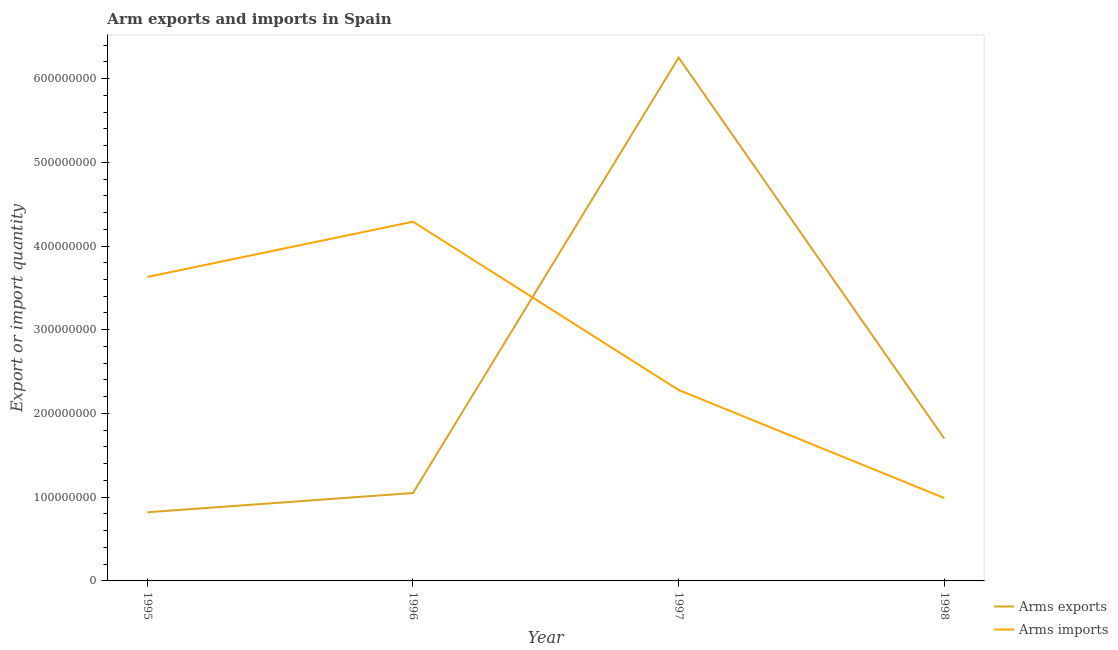How many different coloured lines are there?
Give a very brief answer. 2. Is the number of lines equal to the number of legend labels?
Provide a short and direct response. Yes. What is the arms exports in 1997?
Make the answer very short. 6.25e+08. Across all years, what is the maximum arms exports?
Offer a very short reply. 6.25e+08. Across all years, what is the minimum arms imports?
Offer a very short reply. 9.90e+07. In which year was the arms imports minimum?
Your answer should be very brief. 1998. What is the total arms imports in the graph?
Your answer should be very brief. 1.12e+09. What is the difference between the arms imports in 1995 and that in 1997?
Offer a terse response. 1.35e+08. What is the difference between the arms imports in 1997 and the arms exports in 1998?
Ensure brevity in your answer.  5.80e+07. What is the average arms imports per year?
Your response must be concise. 2.80e+08. In the year 1997, what is the difference between the arms imports and arms exports?
Ensure brevity in your answer.  -3.97e+08. What is the ratio of the arms imports in 1996 to that in 1998?
Give a very brief answer. 4.33. Is the arms imports in 1997 less than that in 1998?
Offer a very short reply. No. Is the difference between the arms imports in 1995 and 1996 greater than the difference between the arms exports in 1995 and 1996?
Your response must be concise. No. What is the difference between the highest and the second highest arms exports?
Ensure brevity in your answer.  4.55e+08. What is the difference between the highest and the lowest arms imports?
Ensure brevity in your answer.  3.30e+08. Is the sum of the arms imports in 1995 and 1998 greater than the maximum arms exports across all years?
Ensure brevity in your answer.  No. Is the arms imports strictly greater than the arms exports over the years?
Keep it short and to the point. No. How many lines are there?
Provide a short and direct response. 2. What is the difference between two consecutive major ticks on the Y-axis?
Provide a short and direct response. 1.00e+08. Are the values on the major ticks of Y-axis written in scientific E-notation?
Your answer should be compact. No. Does the graph contain grids?
Provide a succinct answer. No. How many legend labels are there?
Keep it short and to the point. 2. How are the legend labels stacked?
Your response must be concise. Vertical. What is the title of the graph?
Provide a succinct answer. Arm exports and imports in Spain. Does "Age 65(male)" appear as one of the legend labels in the graph?
Make the answer very short. No. What is the label or title of the X-axis?
Your answer should be compact. Year. What is the label or title of the Y-axis?
Provide a short and direct response. Export or import quantity. What is the Export or import quantity of Arms exports in 1995?
Ensure brevity in your answer.  8.20e+07. What is the Export or import quantity of Arms imports in 1995?
Keep it short and to the point. 3.63e+08. What is the Export or import quantity in Arms exports in 1996?
Make the answer very short. 1.05e+08. What is the Export or import quantity of Arms imports in 1996?
Offer a very short reply. 4.29e+08. What is the Export or import quantity of Arms exports in 1997?
Your answer should be very brief. 6.25e+08. What is the Export or import quantity in Arms imports in 1997?
Give a very brief answer. 2.28e+08. What is the Export or import quantity of Arms exports in 1998?
Your response must be concise. 1.70e+08. What is the Export or import quantity of Arms imports in 1998?
Offer a terse response. 9.90e+07. Across all years, what is the maximum Export or import quantity in Arms exports?
Offer a terse response. 6.25e+08. Across all years, what is the maximum Export or import quantity in Arms imports?
Give a very brief answer. 4.29e+08. Across all years, what is the minimum Export or import quantity in Arms exports?
Your response must be concise. 8.20e+07. Across all years, what is the minimum Export or import quantity of Arms imports?
Offer a very short reply. 9.90e+07. What is the total Export or import quantity of Arms exports in the graph?
Offer a very short reply. 9.82e+08. What is the total Export or import quantity in Arms imports in the graph?
Your response must be concise. 1.12e+09. What is the difference between the Export or import quantity of Arms exports in 1995 and that in 1996?
Offer a very short reply. -2.30e+07. What is the difference between the Export or import quantity in Arms imports in 1995 and that in 1996?
Make the answer very short. -6.60e+07. What is the difference between the Export or import quantity of Arms exports in 1995 and that in 1997?
Give a very brief answer. -5.43e+08. What is the difference between the Export or import quantity of Arms imports in 1995 and that in 1997?
Your answer should be very brief. 1.35e+08. What is the difference between the Export or import quantity in Arms exports in 1995 and that in 1998?
Offer a terse response. -8.80e+07. What is the difference between the Export or import quantity of Arms imports in 1995 and that in 1998?
Provide a short and direct response. 2.64e+08. What is the difference between the Export or import quantity of Arms exports in 1996 and that in 1997?
Provide a short and direct response. -5.20e+08. What is the difference between the Export or import quantity of Arms imports in 1996 and that in 1997?
Give a very brief answer. 2.01e+08. What is the difference between the Export or import quantity in Arms exports in 1996 and that in 1998?
Offer a terse response. -6.50e+07. What is the difference between the Export or import quantity of Arms imports in 1996 and that in 1998?
Provide a short and direct response. 3.30e+08. What is the difference between the Export or import quantity in Arms exports in 1997 and that in 1998?
Your answer should be compact. 4.55e+08. What is the difference between the Export or import quantity in Arms imports in 1997 and that in 1998?
Provide a succinct answer. 1.29e+08. What is the difference between the Export or import quantity in Arms exports in 1995 and the Export or import quantity in Arms imports in 1996?
Keep it short and to the point. -3.47e+08. What is the difference between the Export or import quantity of Arms exports in 1995 and the Export or import quantity of Arms imports in 1997?
Your answer should be very brief. -1.46e+08. What is the difference between the Export or import quantity of Arms exports in 1995 and the Export or import quantity of Arms imports in 1998?
Give a very brief answer. -1.70e+07. What is the difference between the Export or import quantity in Arms exports in 1996 and the Export or import quantity in Arms imports in 1997?
Your answer should be compact. -1.23e+08. What is the difference between the Export or import quantity of Arms exports in 1996 and the Export or import quantity of Arms imports in 1998?
Your answer should be very brief. 6.00e+06. What is the difference between the Export or import quantity of Arms exports in 1997 and the Export or import quantity of Arms imports in 1998?
Offer a very short reply. 5.26e+08. What is the average Export or import quantity of Arms exports per year?
Give a very brief answer. 2.46e+08. What is the average Export or import quantity of Arms imports per year?
Your response must be concise. 2.80e+08. In the year 1995, what is the difference between the Export or import quantity in Arms exports and Export or import quantity in Arms imports?
Provide a short and direct response. -2.81e+08. In the year 1996, what is the difference between the Export or import quantity of Arms exports and Export or import quantity of Arms imports?
Offer a terse response. -3.24e+08. In the year 1997, what is the difference between the Export or import quantity in Arms exports and Export or import quantity in Arms imports?
Keep it short and to the point. 3.97e+08. In the year 1998, what is the difference between the Export or import quantity in Arms exports and Export or import quantity in Arms imports?
Ensure brevity in your answer.  7.10e+07. What is the ratio of the Export or import quantity in Arms exports in 1995 to that in 1996?
Offer a very short reply. 0.78. What is the ratio of the Export or import quantity in Arms imports in 1995 to that in 1996?
Ensure brevity in your answer.  0.85. What is the ratio of the Export or import quantity of Arms exports in 1995 to that in 1997?
Keep it short and to the point. 0.13. What is the ratio of the Export or import quantity of Arms imports in 1995 to that in 1997?
Provide a short and direct response. 1.59. What is the ratio of the Export or import quantity in Arms exports in 1995 to that in 1998?
Offer a very short reply. 0.48. What is the ratio of the Export or import quantity in Arms imports in 1995 to that in 1998?
Your answer should be compact. 3.67. What is the ratio of the Export or import quantity in Arms exports in 1996 to that in 1997?
Keep it short and to the point. 0.17. What is the ratio of the Export or import quantity of Arms imports in 1996 to that in 1997?
Your answer should be very brief. 1.88. What is the ratio of the Export or import quantity in Arms exports in 1996 to that in 1998?
Offer a terse response. 0.62. What is the ratio of the Export or import quantity in Arms imports in 1996 to that in 1998?
Give a very brief answer. 4.33. What is the ratio of the Export or import quantity in Arms exports in 1997 to that in 1998?
Provide a short and direct response. 3.68. What is the ratio of the Export or import quantity of Arms imports in 1997 to that in 1998?
Your response must be concise. 2.3. What is the difference between the highest and the second highest Export or import quantity in Arms exports?
Keep it short and to the point. 4.55e+08. What is the difference between the highest and the second highest Export or import quantity in Arms imports?
Offer a very short reply. 6.60e+07. What is the difference between the highest and the lowest Export or import quantity of Arms exports?
Make the answer very short. 5.43e+08. What is the difference between the highest and the lowest Export or import quantity in Arms imports?
Ensure brevity in your answer.  3.30e+08. 